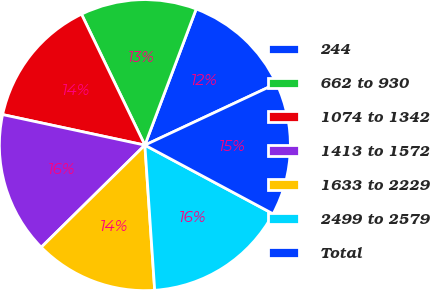Convert chart. <chart><loc_0><loc_0><loc_500><loc_500><pie_chart><fcel>244<fcel>662 to 930<fcel>1074 to 1342<fcel>1413 to 1572<fcel>1633 to 2229<fcel>2499 to 2579<fcel>Total<nl><fcel>12.29%<fcel>12.91%<fcel>14.46%<fcel>15.75%<fcel>13.69%<fcel>16.09%<fcel>14.8%<nl></chart> 